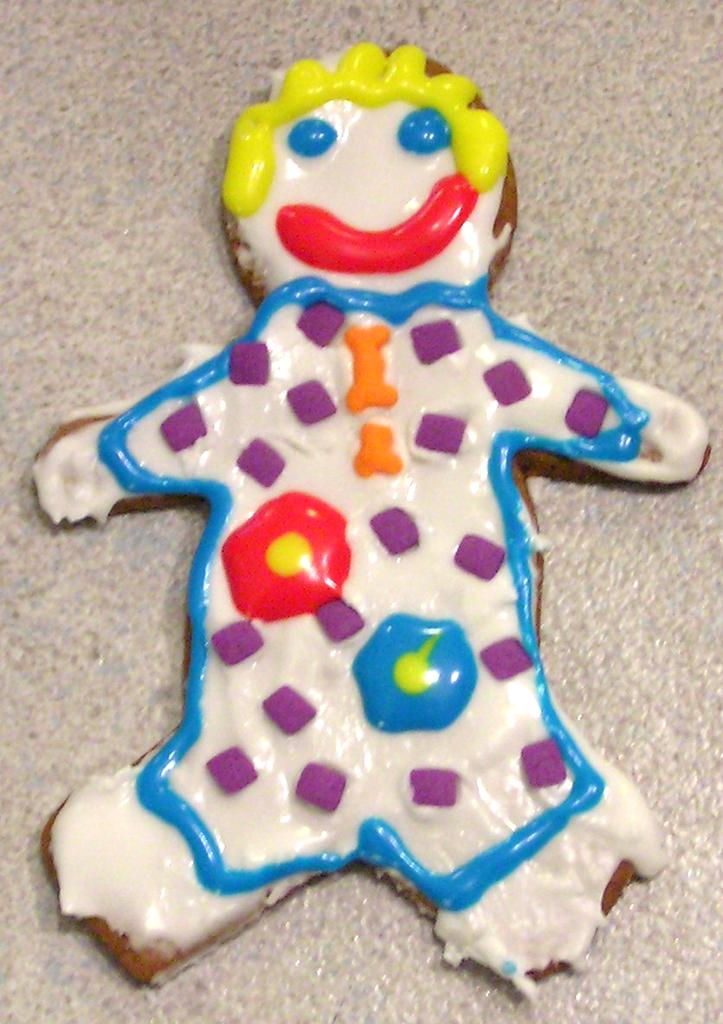What is the color of the surface in the image? The surface in the image is white. What is placed on the white surface? There is a cookie on the white surface. Can you describe the appearance of the cookie? The cookie has multiple colors, including brown, white, red, yellow, orange, blue, and pink. What type of fruit can be seen growing on the tree in the image? There is no tree or fruit present in the image; it features a cookie on a white surface. 